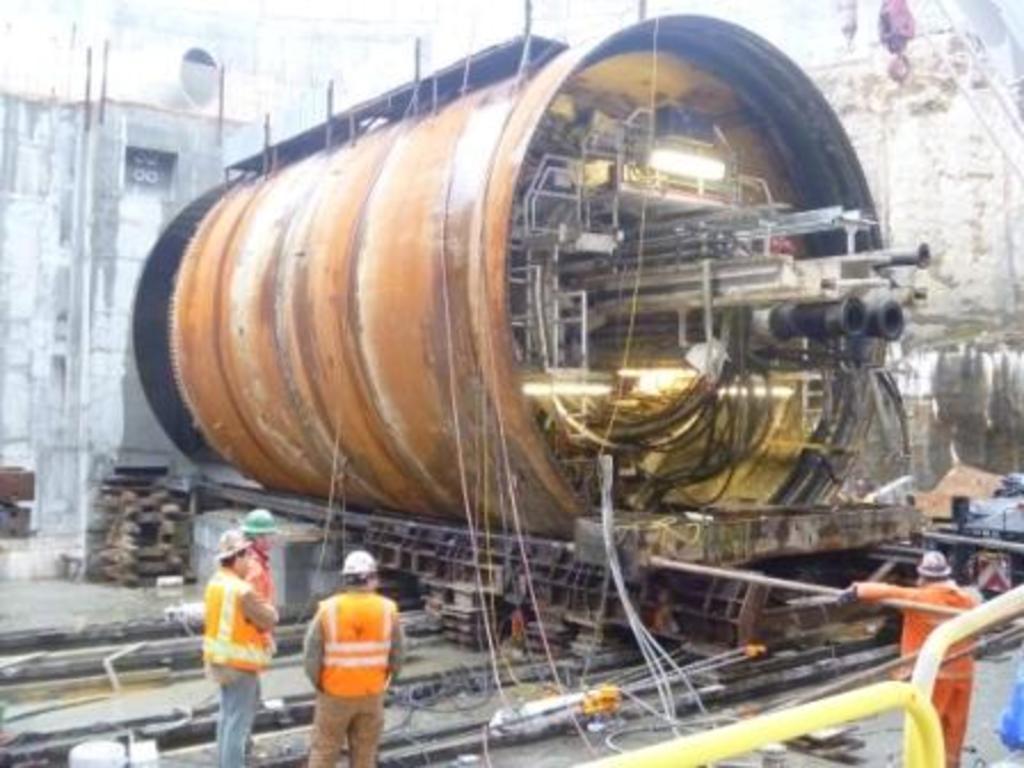In one or two sentences, can you explain what this image depicts? In this picture, we can see a cylindrical container and some objects in it, we can see a few people, and the ground with some objects, wires, building, and in the bottom right corner we can see some yellow color object. 